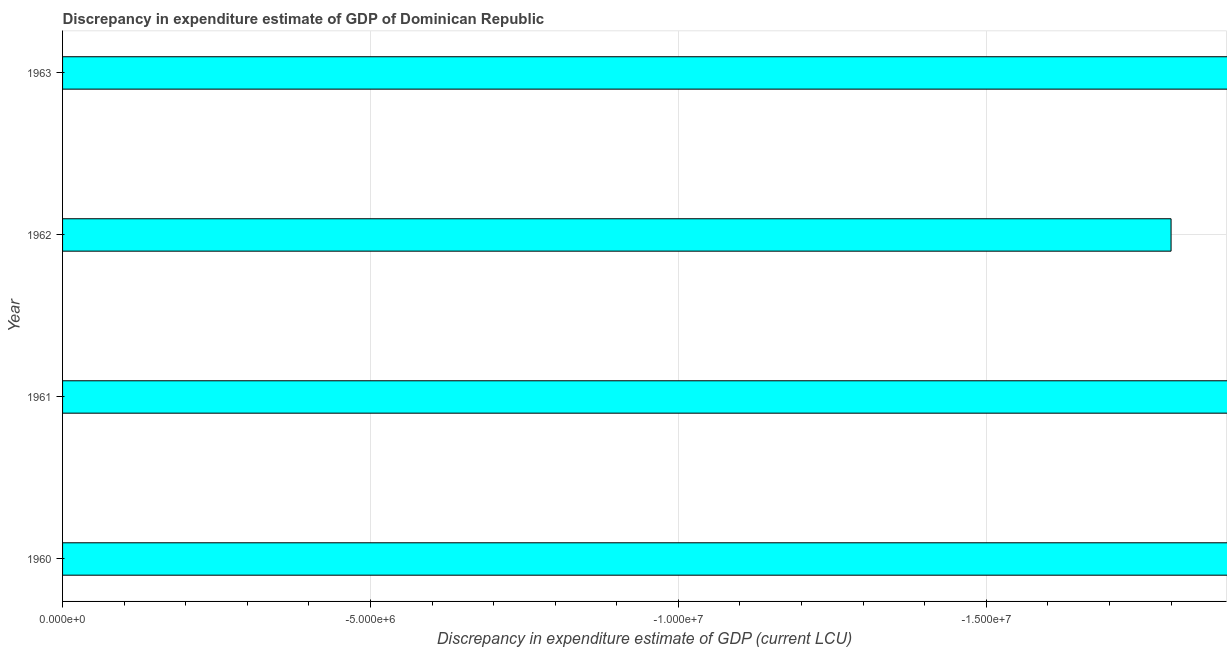Does the graph contain any zero values?
Offer a very short reply. Yes. Does the graph contain grids?
Make the answer very short. Yes. What is the title of the graph?
Your answer should be compact. Discrepancy in expenditure estimate of GDP of Dominican Republic. What is the label or title of the X-axis?
Ensure brevity in your answer.  Discrepancy in expenditure estimate of GDP (current LCU). What is the discrepancy in expenditure estimate of gdp in 1962?
Make the answer very short. 0. Across all years, what is the minimum discrepancy in expenditure estimate of gdp?
Make the answer very short. 0. What is the sum of the discrepancy in expenditure estimate of gdp?
Your response must be concise. 0. What is the average discrepancy in expenditure estimate of gdp per year?
Provide a succinct answer. 0. How many years are there in the graph?
Offer a terse response. 4. Are the values on the major ticks of X-axis written in scientific E-notation?
Give a very brief answer. Yes. What is the Discrepancy in expenditure estimate of GDP (current LCU) in 1962?
Keep it short and to the point. 0. 